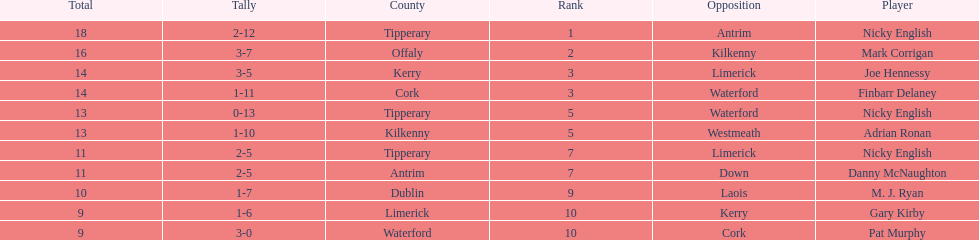Parse the table in full. {'header': ['Total', 'Tally', 'County', 'Rank', 'Opposition', 'Player'], 'rows': [['18', '2-12', 'Tipperary', '1', 'Antrim', 'Nicky English'], ['16', '3-7', 'Offaly', '2', 'Kilkenny', 'Mark Corrigan'], ['14', '3-5', 'Kerry', '3', 'Limerick', 'Joe Hennessy'], ['14', '1-11', 'Cork', '3', 'Waterford', 'Finbarr Delaney'], ['13', '0-13', 'Tipperary', '5', 'Waterford', 'Nicky English'], ['13', '1-10', 'Kilkenny', '5', 'Westmeath', 'Adrian Ronan'], ['11', '2-5', 'Tipperary', '7', 'Limerick', 'Nicky English'], ['11', '2-5', 'Antrim', '7', 'Down', 'Danny McNaughton'], ['10', '1-7', 'Dublin', '9', 'Laois', 'M. J. Ryan'], ['9', '1-6', 'Limerick', '10', 'Kerry', 'Gary Kirby'], ['9', '3-0', 'Waterford', '10', 'Cork', 'Pat Murphy']]} What was the combined total of nicky english and mark corrigan? 34. 